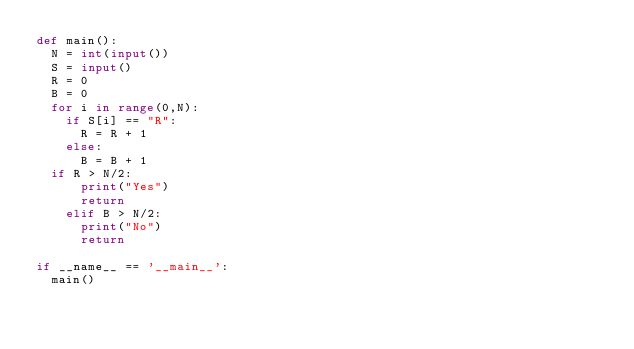<code> <loc_0><loc_0><loc_500><loc_500><_Python_>def main():
  N = int(input())
  S = input()
  R = 0
  B = 0
  for i in range(0,N):
    if S[i] == "R":
      R = R + 1
    else:
      B = B + 1
	if R > N/2:
      print("Yes")
      return
    elif B > N/2:
      print("No")
      return
    
if __name__ == '__main__':
  main()
</code> 